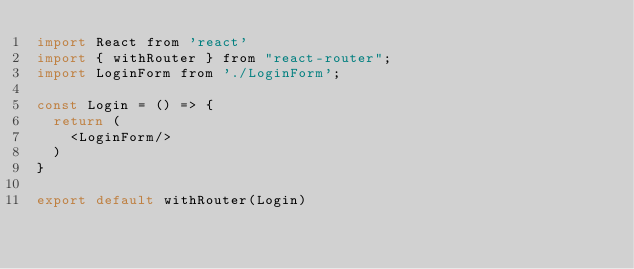Convert code to text. <code><loc_0><loc_0><loc_500><loc_500><_JavaScript_>import React from 'react'
import { withRouter } from "react-router";
import LoginForm from './LoginForm';

const Login = () => {
  return (
    <LoginForm/>
  )
}

export default withRouter(Login)
</code> 